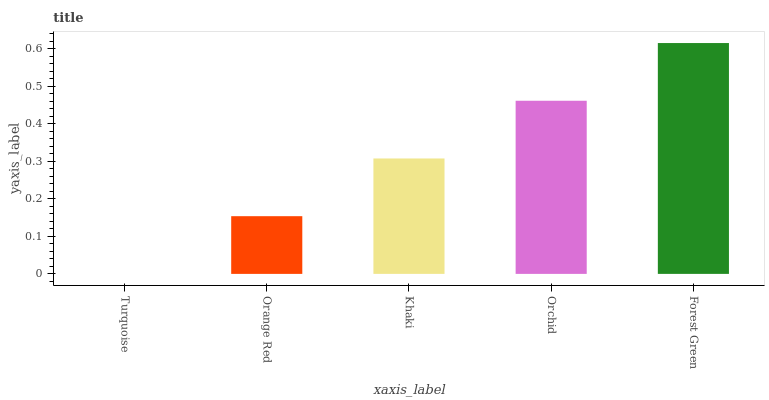Is Turquoise the minimum?
Answer yes or no. Yes. Is Forest Green the maximum?
Answer yes or no. Yes. Is Orange Red the minimum?
Answer yes or no. No. Is Orange Red the maximum?
Answer yes or no. No. Is Orange Red greater than Turquoise?
Answer yes or no. Yes. Is Turquoise less than Orange Red?
Answer yes or no. Yes. Is Turquoise greater than Orange Red?
Answer yes or no. No. Is Orange Red less than Turquoise?
Answer yes or no. No. Is Khaki the high median?
Answer yes or no. Yes. Is Khaki the low median?
Answer yes or no. Yes. Is Turquoise the high median?
Answer yes or no. No. Is Orchid the low median?
Answer yes or no. No. 